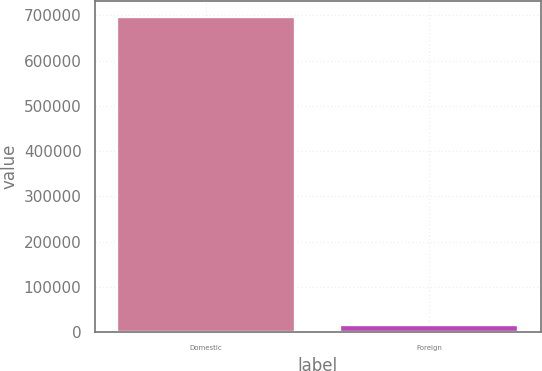Convert chart. <chart><loc_0><loc_0><loc_500><loc_500><bar_chart><fcel>Domestic<fcel>Foreign<nl><fcel>697062<fcel>16406<nl></chart> 